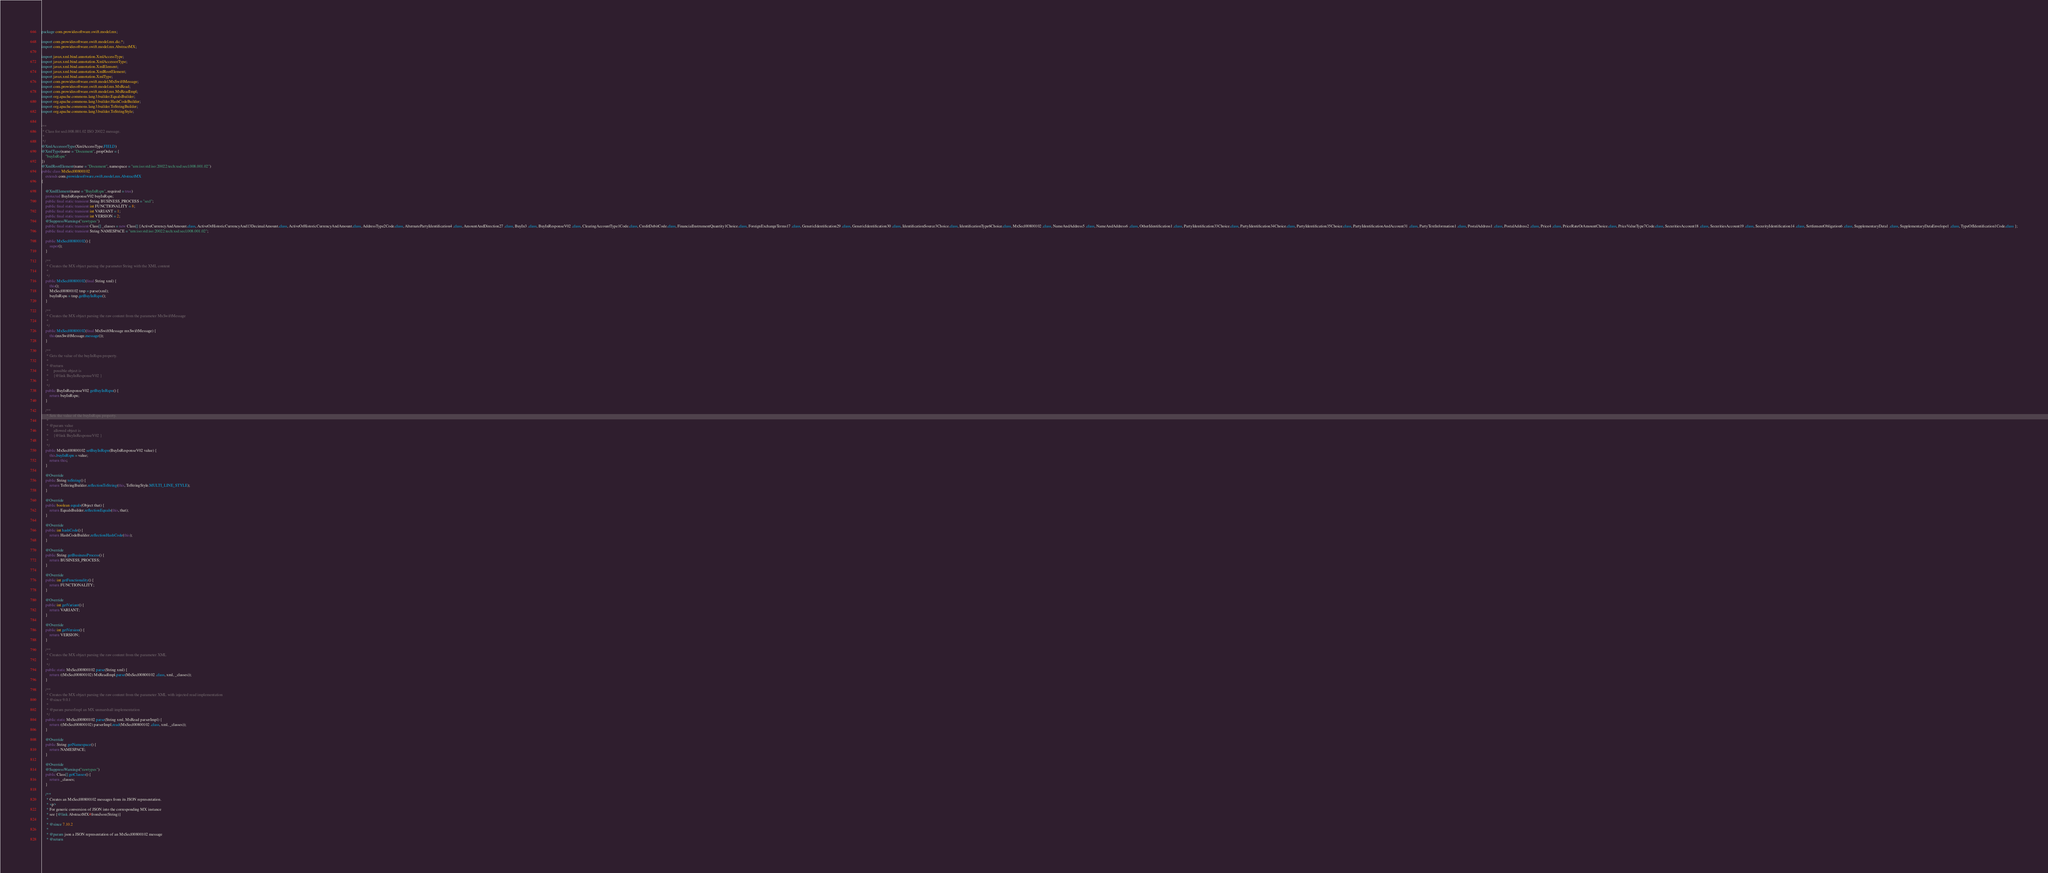Convert code to text. <code><loc_0><loc_0><loc_500><loc_500><_Java_>
package com.prowidesoftware.swift.model.mx;

import com.prowidesoftware.swift.model.mx.dic.*;
import com.prowidesoftware.swift.model.mx.AbstractMX;

import javax.xml.bind.annotation.XmlAccessType;
import javax.xml.bind.annotation.XmlAccessorType;
import javax.xml.bind.annotation.XmlElement;
import javax.xml.bind.annotation.XmlRootElement;
import javax.xml.bind.annotation.XmlType;
import com.prowidesoftware.swift.model.MxSwiftMessage;
import com.prowidesoftware.swift.model.mx.MxRead;
import com.prowidesoftware.swift.model.mx.MxReadImpl;
import org.apache.commons.lang3.builder.EqualsBuilder;
import org.apache.commons.lang3.builder.HashCodeBuilder;
import org.apache.commons.lang3.builder.ToStringBuilder;
import org.apache.commons.lang3.builder.ToStringStyle;


/**
 * Class for secl.008.001.02 ISO 20022 message.
 * 
 */
@XmlAccessorType(XmlAccessType.FIELD)
@XmlType(name = "Document", propOrder = {
    "buyInRspn"
})
@XmlRootElement(name = "Document", namespace = "urn:iso:std:iso:20022:tech:xsd:secl.008.001.02")
public class MxSecl00800102
    extends com.prowidesoftware.swift.model.mx.AbstractMX
{

    @XmlElement(name = "BuyInRspn", required = true)
    protected BuyInResponseV02 buyInRspn;
    public final static transient String BUSINESS_PROCESS = "secl";
    public final static transient int FUNCTIONALITY = 8;
    public final static transient int VARIANT = 1;
    public final static transient int VERSION = 2;
    @SuppressWarnings("rawtypes")
    public final static transient Class[] _classes = new Class[] {ActiveCurrencyAndAmount.class, ActiveOrHistoricCurrencyAnd13DecimalAmount.class, ActiveOrHistoricCurrencyAndAmount.class, AddressType2Code.class, AlternatePartyIdentification4 .class, AmountAndDirection27 .class, BuyIn3 .class, BuyInResponseV02 .class, ClearingAccountType1Code.class, CreditDebitCode.class, FinancialInstrumentQuantity1Choice.class, ForeignExchangeTerms17 .class, GenericIdentification29 .class, GenericIdentification30 .class, IdentificationSource3Choice.class, IdentificationType6Choice.class, MxSecl00800102 .class, NameAndAddress5 .class, NameAndAddress6 .class, OtherIdentification1 .class, PartyIdentification33Choice.class, PartyIdentification34Choice.class, PartyIdentification35Choice.class, PartyIdentificationAndAccount31 .class, PartyTextInformation1 .class, PostalAddress1 .class, PostalAddress2 .class, Price4 .class, PriceRateOrAmountChoice.class, PriceValueType7Code.class, SecuritiesAccount18 .class, SecuritiesAccount19 .class, SecurityIdentification14 .class, SettlementObligation6 .class, SupplementaryData1 .class, SupplementaryDataEnvelope1 .class, TypeOfIdentification1Code.class };
    public final static transient String NAMESPACE = "urn:iso:std:iso:20022:tech:xsd:secl.008.001.02";

    public MxSecl00800102() {
        super();
    }

    /**
     * Creates the MX object parsing the parameter String with the XML content
     * 
     */
    public MxSecl00800102(final String xml) {
        this();
        MxSecl00800102 tmp = parse(xml);
        buyInRspn = tmp.getBuyInRspn();
    }

    /**
     * Creates the MX object parsing the raw content from the parameter MxSwiftMessage
     * 
     */
    public MxSecl00800102(final MxSwiftMessage mxSwiftMessage) {
        this(mxSwiftMessage.message());
    }

    /**
     * Gets the value of the buyInRspn property.
     * 
     * @return
     *     possible object is
     *     {@link BuyInResponseV02 }
     *     
     */
    public BuyInResponseV02 getBuyInRspn() {
        return buyInRspn;
    }

    /**
     * Sets the value of the buyInRspn property.
     * 
     * @param value
     *     allowed object is
     *     {@link BuyInResponseV02 }
     *     
     */
    public MxSecl00800102 setBuyInRspn(BuyInResponseV02 value) {
        this.buyInRspn = value;
        return this;
    }

    @Override
    public String toString() {
        return ToStringBuilder.reflectionToString(this, ToStringStyle.MULTI_LINE_STYLE);
    }

    @Override
    public boolean equals(Object that) {
        return EqualsBuilder.reflectionEquals(this, that);
    }

    @Override
    public int hashCode() {
        return HashCodeBuilder.reflectionHashCode(this);
    }

    @Override
    public String getBusinessProcess() {
        return BUSINESS_PROCESS;
    }

    @Override
    public int getFunctionality() {
        return FUNCTIONALITY;
    }

    @Override
    public int getVariant() {
        return VARIANT;
    }

    @Override
    public int getVersion() {
        return VERSION;
    }

    /**
     * Creates the MX object parsing the raw content from the parameter XML
     * 
     */
    public static MxSecl00800102 parse(String xml) {
        return ((MxSecl00800102) MxReadImpl.parse(MxSecl00800102 .class, xml, _classes));
    }

    /**
     * Creates the MX object parsing the raw content from the parameter XML with injected read implementation
     * @since 9.0.1
     * 
     * @param parserImpl an MX unmarshall implementation
     */
    public static MxSecl00800102 parse(String xml, MxRead parserImpl) {
        return ((MxSecl00800102) parserImpl.read(MxSecl00800102 .class, xml, _classes));
    }

    @Override
    public String getNamespace() {
        return NAMESPACE;
    }

    @Override
    @SuppressWarnings("rawtypes")
    public Class[] getClasses() {
        return _classes;
    }

    /**
     * Creates an MxSecl00800102 messages from its JSON representation.
     * <p>
     * For generic conversion of JSON into the corresponding MX instance 
     * see {@link AbstractMX#fromJson(String)}
     * 
     * @since 7.10.2
     * 
     * @param json a JSON representation of an MxSecl00800102 message
     * @return</code> 